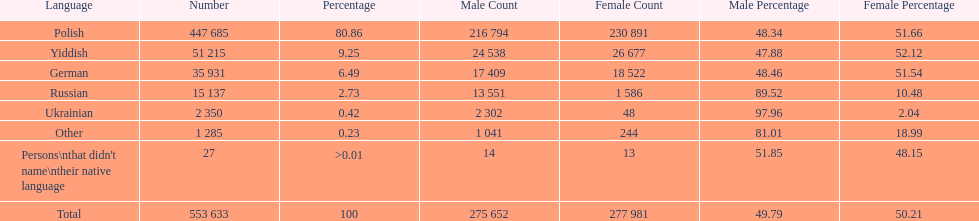Parse the table in full. {'header': ['Language', 'Number', 'Percentage', 'Male Count', 'Female Count', 'Male Percentage', 'Female Percentage'], 'rows': [['Polish', '447 685', '80.86', '216 794', '230 891', '48.34', '51.66'], ['Yiddish', '51 215', '9.25', '24 538', '26 677', '47.88', '52.12'], ['German', '35 931', '6.49', '17 409', '18 522', '48.46', '51.54'], ['Russian', '15 137', '2.73', '13 551', '1 586', '89.52', '10.48'], ['Ukrainian', '2 350', '0.42', '2 302', '48', '97.96', '2.04'], ['Other', '1 285', '0.23', '1 041', '244', '81.01', '18.99'], ["Persons\\nthat didn't name\\ntheir native language", '27', '>0.01', '14', '13', '51.85', '48.15'], ['Total', '553 633', '100', '275 652', '277 981', '49.79', '50.21']]} What are all of the languages? Polish, Yiddish, German, Russian, Ukrainian, Other, Persons\nthat didn't name\ntheir native language. And how many people speak these languages? 447 685, 51 215, 35 931, 15 137, 2 350, 1 285, 27. Which language is used by most people? Polish. 